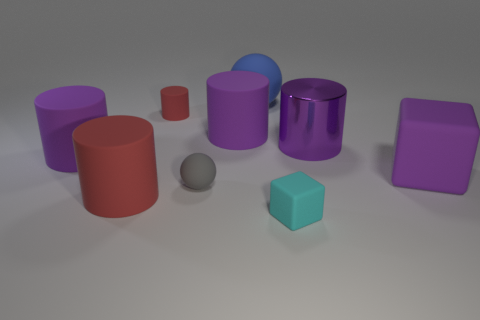Is there anything else that has the same material as the tiny red cylinder?
Give a very brief answer. Yes. The cube that is the same color as the large metallic object is what size?
Offer a terse response. Large. There is a red cylinder behind the tiny gray object; what size is it?
Keep it short and to the point. Small. What is the ball that is behind the thing that is on the left side of the big red rubber object made of?
Ensure brevity in your answer.  Rubber. There is a large matte cylinder behind the big purple rubber object that is to the left of the small red rubber cylinder; what number of big purple matte objects are in front of it?
Make the answer very short. 2. Is the material of the block that is to the right of the tiny cyan thing the same as the red cylinder that is in front of the gray object?
Ensure brevity in your answer.  Yes. There is a block that is the same color as the metal object; what is its material?
Your answer should be very brief. Rubber. What number of big red rubber objects have the same shape as the large metallic thing?
Provide a short and direct response. 1. Are there more small gray rubber spheres that are on the left side of the small red cylinder than green cylinders?
Offer a terse response. No. What is the shape of the large object that is in front of the purple thing that is in front of the purple cylinder that is on the left side of the tiny gray matte object?
Keep it short and to the point. Cylinder. 